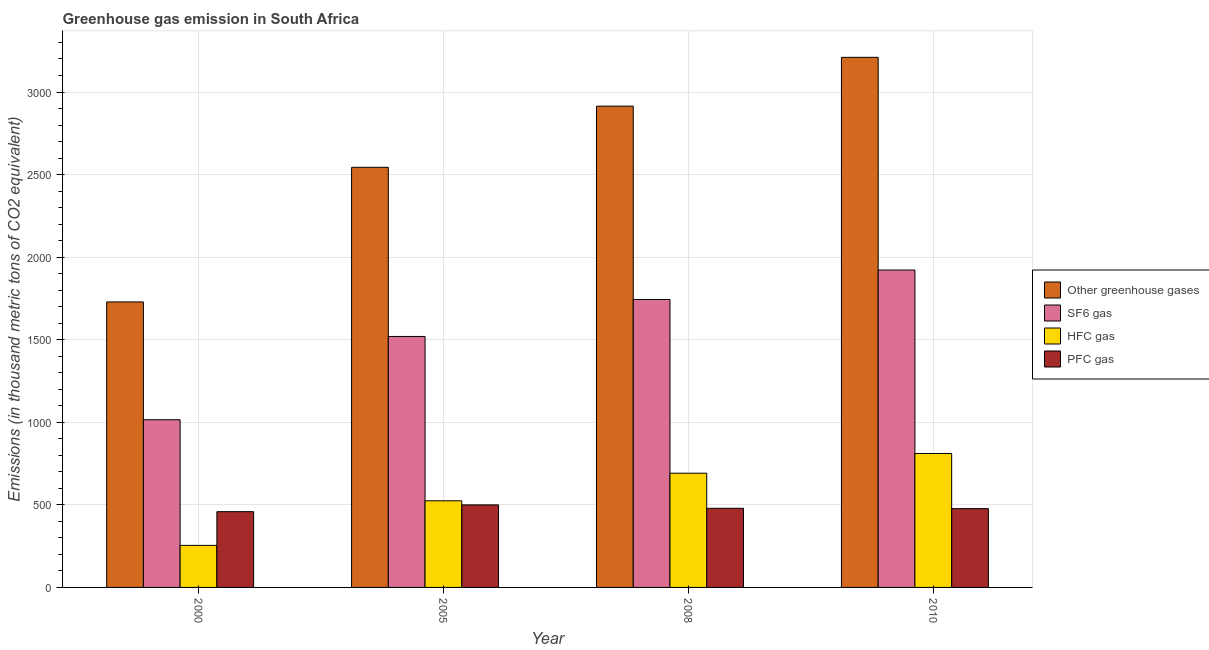How many different coloured bars are there?
Your answer should be very brief. 4. How many groups of bars are there?
Offer a very short reply. 4. Are the number of bars per tick equal to the number of legend labels?
Make the answer very short. Yes. How many bars are there on the 1st tick from the left?
Your answer should be compact. 4. In how many cases, is the number of bars for a given year not equal to the number of legend labels?
Provide a short and direct response. 0. What is the emission of pfc gas in 2010?
Offer a terse response. 477. Across all years, what is the maximum emission of hfc gas?
Provide a succinct answer. 811. Across all years, what is the minimum emission of pfc gas?
Offer a terse response. 458.8. In which year was the emission of pfc gas maximum?
Keep it short and to the point. 2005. In which year was the emission of sf6 gas minimum?
Offer a terse response. 2000. What is the total emission of pfc gas in the graph?
Keep it short and to the point. 1914.8. What is the difference between the emission of sf6 gas in 2000 and that in 2008?
Your answer should be compact. -728.2. What is the difference between the emission of hfc gas in 2005 and the emission of pfc gas in 2000?
Your response must be concise. 269.9. What is the average emission of pfc gas per year?
Your answer should be compact. 478.7. In the year 2005, what is the difference between the emission of hfc gas and emission of sf6 gas?
Keep it short and to the point. 0. In how many years, is the emission of sf6 gas greater than 2500 thousand metric tons?
Make the answer very short. 0. What is the ratio of the emission of sf6 gas in 2005 to that in 2008?
Keep it short and to the point. 0.87. Is the emission of sf6 gas in 2005 less than that in 2008?
Keep it short and to the point. Yes. What is the difference between the highest and the second highest emission of sf6 gas?
Offer a terse response. 178.4. What is the difference between the highest and the lowest emission of greenhouse gases?
Ensure brevity in your answer.  1481.2. What does the 4th bar from the left in 2005 represents?
Your answer should be very brief. PFC gas. What does the 3rd bar from the right in 2005 represents?
Offer a terse response. SF6 gas. Are the values on the major ticks of Y-axis written in scientific E-notation?
Provide a succinct answer. No. Where does the legend appear in the graph?
Give a very brief answer. Center right. How many legend labels are there?
Offer a terse response. 4. How are the legend labels stacked?
Provide a short and direct response. Vertical. What is the title of the graph?
Provide a succinct answer. Greenhouse gas emission in South Africa. What is the label or title of the Y-axis?
Give a very brief answer. Emissions (in thousand metric tons of CO2 equivalent). What is the Emissions (in thousand metric tons of CO2 equivalent) in Other greenhouse gases in 2000?
Give a very brief answer. 1728.8. What is the Emissions (in thousand metric tons of CO2 equivalent) of SF6 gas in 2000?
Your answer should be compact. 1015.4. What is the Emissions (in thousand metric tons of CO2 equivalent) in HFC gas in 2000?
Make the answer very short. 254.6. What is the Emissions (in thousand metric tons of CO2 equivalent) of PFC gas in 2000?
Provide a succinct answer. 458.8. What is the Emissions (in thousand metric tons of CO2 equivalent) of Other greenhouse gases in 2005?
Provide a short and direct response. 2544. What is the Emissions (in thousand metric tons of CO2 equivalent) of SF6 gas in 2005?
Make the answer very short. 1519.7. What is the Emissions (in thousand metric tons of CO2 equivalent) in HFC gas in 2005?
Your answer should be compact. 524.5. What is the Emissions (in thousand metric tons of CO2 equivalent) of PFC gas in 2005?
Provide a succinct answer. 499.8. What is the Emissions (in thousand metric tons of CO2 equivalent) in Other greenhouse gases in 2008?
Provide a short and direct response. 2914.4. What is the Emissions (in thousand metric tons of CO2 equivalent) of SF6 gas in 2008?
Your answer should be very brief. 1743.6. What is the Emissions (in thousand metric tons of CO2 equivalent) of HFC gas in 2008?
Keep it short and to the point. 691.6. What is the Emissions (in thousand metric tons of CO2 equivalent) in PFC gas in 2008?
Offer a very short reply. 479.2. What is the Emissions (in thousand metric tons of CO2 equivalent) in Other greenhouse gases in 2010?
Your response must be concise. 3210. What is the Emissions (in thousand metric tons of CO2 equivalent) in SF6 gas in 2010?
Provide a succinct answer. 1922. What is the Emissions (in thousand metric tons of CO2 equivalent) in HFC gas in 2010?
Make the answer very short. 811. What is the Emissions (in thousand metric tons of CO2 equivalent) in PFC gas in 2010?
Offer a very short reply. 477. Across all years, what is the maximum Emissions (in thousand metric tons of CO2 equivalent) of Other greenhouse gases?
Ensure brevity in your answer.  3210. Across all years, what is the maximum Emissions (in thousand metric tons of CO2 equivalent) of SF6 gas?
Your answer should be compact. 1922. Across all years, what is the maximum Emissions (in thousand metric tons of CO2 equivalent) in HFC gas?
Give a very brief answer. 811. Across all years, what is the maximum Emissions (in thousand metric tons of CO2 equivalent) of PFC gas?
Make the answer very short. 499.8. Across all years, what is the minimum Emissions (in thousand metric tons of CO2 equivalent) of Other greenhouse gases?
Offer a terse response. 1728.8. Across all years, what is the minimum Emissions (in thousand metric tons of CO2 equivalent) of SF6 gas?
Give a very brief answer. 1015.4. Across all years, what is the minimum Emissions (in thousand metric tons of CO2 equivalent) of HFC gas?
Provide a succinct answer. 254.6. Across all years, what is the minimum Emissions (in thousand metric tons of CO2 equivalent) in PFC gas?
Offer a very short reply. 458.8. What is the total Emissions (in thousand metric tons of CO2 equivalent) of Other greenhouse gases in the graph?
Your answer should be compact. 1.04e+04. What is the total Emissions (in thousand metric tons of CO2 equivalent) of SF6 gas in the graph?
Make the answer very short. 6200.7. What is the total Emissions (in thousand metric tons of CO2 equivalent) in HFC gas in the graph?
Offer a very short reply. 2281.7. What is the total Emissions (in thousand metric tons of CO2 equivalent) of PFC gas in the graph?
Offer a terse response. 1914.8. What is the difference between the Emissions (in thousand metric tons of CO2 equivalent) of Other greenhouse gases in 2000 and that in 2005?
Provide a succinct answer. -815.2. What is the difference between the Emissions (in thousand metric tons of CO2 equivalent) of SF6 gas in 2000 and that in 2005?
Give a very brief answer. -504.3. What is the difference between the Emissions (in thousand metric tons of CO2 equivalent) in HFC gas in 2000 and that in 2005?
Keep it short and to the point. -269.9. What is the difference between the Emissions (in thousand metric tons of CO2 equivalent) of PFC gas in 2000 and that in 2005?
Your answer should be compact. -41. What is the difference between the Emissions (in thousand metric tons of CO2 equivalent) of Other greenhouse gases in 2000 and that in 2008?
Provide a succinct answer. -1185.6. What is the difference between the Emissions (in thousand metric tons of CO2 equivalent) in SF6 gas in 2000 and that in 2008?
Provide a short and direct response. -728.2. What is the difference between the Emissions (in thousand metric tons of CO2 equivalent) of HFC gas in 2000 and that in 2008?
Provide a short and direct response. -437. What is the difference between the Emissions (in thousand metric tons of CO2 equivalent) of PFC gas in 2000 and that in 2008?
Offer a very short reply. -20.4. What is the difference between the Emissions (in thousand metric tons of CO2 equivalent) of Other greenhouse gases in 2000 and that in 2010?
Keep it short and to the point. -1481.2. What is the difference between the Emissions (in thousand metric tons of CO2 equivalent) of SF6 gas in 2000 and that in 2010?
Provide a short and direct response. -906.6. What is the difference between the Emissions (in thousand metric tons of CO2 equivalent) of HFC gas in 2000 and that in 2010?
Provide a short and direct response. -556.4. What is the difference between the Emissions (in thousand metric tons of CO2 equivalent) of PFC gas in 2000 and that in 2010?
Make the answer very short. -18.2. What is the difference between the Emissions (in thousand metric tons of CO2 equivalent) of Other greenhouse gases in 2005 and that in 2008?
Offer a terse response. -370.4. What is the difference between the Emissions (in thousand metric tons of CO2 equivalent) in SF6 gas in 2005 and that in 2008?
Make the answer very short. -223.9. What is the difference between the Emissions (in thousand metric tons of CO2 equivalent) of HFC gas in 2005 and that in 2008?
Ensure brevity in your answer.  -167.1. What is the difference between the Emissions (in thousand metric tons of CO2 equivalent) of PFC gas in 2005 and that in 2008?
Ensure brevity in your answer.  20.6. What is the difference between the Emissions (in thousand metric tons of CO2 equivalent) in Other greenhouse gases in 2005 and that in 2010?
Your answer should be compact. -666. What is the difference between the Emissions (in thousand metric tons of CO2 equivalent) in SF6 gas in 2005 and that in 2010?
Your answer should be very brief. -402.3. What is the difference between the Emissions (in thousand metric tons of CO2 equivalent) in HFC gas in 2005 and that in 2010?
Your answer should be very brief. -286.5. What is the difference between the Emissions (in thousand metric tons of CO2 equivalent) of PFC gas in 2005 and that in 2010?
Your answer should be very brief. 22.8. What is the difference between the Emissions (in thousand metric tons of CO2 equivalent) in Other greenhouse gases in 2008 and that in 2010?
Offer a terse response. -295.6. What is the difference between the Emissions (in thousand metric tons of CO2 equivalent) of SF6 gas in 2008 and that in 2010?
Make the answer very short. -178.4. What is the difference between the Emissions (in thousand metric tons of CO2 equivalent) in HFC gas in 2008 and that in 2010?
Provide a succinct answer. -119.4. What is the difference between the Emissions (in thousand metric tons of CO2 equivalent) of PFC gas in 2008 and that in 2010?
Keep it short and to the point. 2.2. What is the difference between the Emissions (in thousand metric tons of CO2 equivalent) in Other greenhouse gases in 2000 and the Emissions (in thousand metric tons of CO2 equivalent) in SF6 gas in 2005?
Provide a short and direct response. 209.1. What is the difference between the Emissions (in thousand metric tons of CO2 equivalent) of Other greenhouse gases in 2000 and the Emissions (in thousand metric tons of CO2 equivalent) of HFC gas in 2005?
Your answer should be compact. 1204.3. What is the difference between the Emissions (in thousand metric tons of CO2 equivalent) in Other greenhouse gases in 2000 and the Emissions (in thousand metric tons of CO2 equivalent) in PFC gas in 2005?
Keep it short and to the point. 1229. What is the difference between the Emissions (in thousand metric tons of CO2 equivalent) of SF6 gas in 2000 and the Emissions (in thousand metric tons of CO2 equivalent) of HFC gas in 2005?
Offer a terse response. 490.9. What is the difference between the Emissions (in thousand metric tons of CO2 equivalent) of SF6 gas in 2000 and the Emissions (in thousand metric tons of CO2 equivalent) of PFC gas in 2005?
Your response must be concise. 515.6. What is the difference between the Emissions (in thousand metric tons of CO2 equivalent) of HFC gas in 2000 and the Emissions (in thousand metric tons of CO2 equivalent) of PFC gas in 2005?
Offer a terse response. -245.2. What is the difference between the Emissions (in thousand metric tons of CO2 equivalent) in Other greenhouse gases in 2000 and the Emissions (in thousand metric tons of CO2 equivalent) in SF6 gas in 2008?
Provide a succinct answer. -14.8. What is the difference between the Emissions (in thousand metric tons of CO2 equivalent) in Other greenhouse gases in 2000 and the Emissions (in thousand metric tons of CO2 equivalent) in HFC gas in 2008?
Make the answer very short. 1037.2. What is the difference between the Emissions (in thousand metric tons of CO2 equivalent) in Other greenhouse gases in 2000 and the Emissions (in thousand metric tons of CO2 equivalent) in PFC gas in 2008?
Provide a succinct answer. 1249.6. What is the difference between the Emissions (in thousand metric tons of CO2 equivalent) in SF6 gas in 2000 and the Emissions (in thousand metric tons of CO2 equivalent) in HFC gas in 2008?
Give a very brief answer. 323.8. What is the difference between the Emissions (in thousand metric tons of CO2 equivalent) of SF6 gas in 2000 and the Emissions (in thousand metric tons of CO2 equivalent) of PFC gas in 2008?
Provide a succinct answer. 536.2. What is the difference between the Emissions (in thousand metric tons of CO2 equivalent) of HFC gas in 2000 and the Emissions (in thousand metric tons of CO2 equivalent) of PFC gas in 2008?
Offer a very short reply. -224.6. What is the difference between the Emissions (in thousand metric tons of CO2 equivalent) in Other greenhouse gases in 2000 and the Emissions (in thousand metric tons of CO2 equivalent) in SF6 gas in 2010?
Your answer should be very brief. -193.2. What is the difference between the Emissions (in thousand metric tons of CO2 equivalent) of Other greenhouse gases in 2000 and the Emissions (in thousand metric tons of CO2 equivalent) of HFC gas in 2010?
Your response must be concise. 917.8. What is the difference between the Emissions (in thousand metric tons of CO2 equivalent) in Other greenhouse gases in 2000 and the Emissions (in thousand metric tons of CO2 equivalent) in PFC gas in 2010?
Make the answer very short. 1251.8. What is the difference between the Emissions (in thousand metric tons of CO2 equivalent) of SF6 gas in 2000 and the Emissions (in thousand metric tons of CO2 equivalent) of HFC gas in 2010?
Keep it short and to the point. 204.4. What is the difference between the Emissions (in thousand metric tons of CO2 equivalent) of SF6 gas in 2000 and the Emissions (in thousand metric tons of CO2 equivalent) of PFC gas in 2010?
Offer a terse response. 538.4. What is the difference between the Emissions (in thousand metric tons of CO2 equivalent) of HFC gas in 2000 and the Emissions (in thousand metric tons of CO2 equivalent) of PFC gas in 2010?
Your response must be concise. -222.4. What is the difference between the Emissions (in thousand metric tons of CO2 equivalent) in Other greenhouse gases in 2005 and the Emissions (in thousand metric tons of CO2 equivalent) in SF6 gas in 2008?
Offer a very short reply. 800.4. What is the difference between the Emissions (in thousand metric tons of CO2 equivalent) in Other greenhouse gases in 2005 and the Emissions (in thousand metric tons of CO2 equivalent) in HFC gas in 2008?
Your answer should be very brief. 1852.4. What is the difference between the Emissions (in thousand metric tons of CO2 equivalent) in Other greenhouse gases in 2005 and the Emissions (in thousand metric tons of CO2 equivalent) in PFC gas in 2008?
Provide a short and direct response. 2064.8. What is the difference between the Emissions (in thousand metric tons of CO2 equivalent) of SF6 gas in 2005 and the Emissions (in thousand metric tons of CO2 equivalent) of HFC gas in 2008?
Your answer should be very brief. 828.1. What is the difference between the Emissions (in thousand metric tons of CO2 equivalent) of SF6 gas in 2005 and the Emissions (in thousand metric tons of CO2 equivalent) of PFC gas in 2008?
Your answer should be compact. 1040.5. What is the difference between the Emissions (in thousand metric tons of CO2 equivalent) in HFC gas in 2005 and the Emissions (in thousand metric tons of CO2 equivalent) in PFC gas in 2008?
Offer a terse response. 45.3. What is the difference between the Emissions (in thousand metric tons of CO2 equivalent) of Other greenhouse gases in 2005 and the Emissions (in thousand metric tons of CO2 equivalent) of SF6 gas in 2010?
Ensure brevity in your answer.  622. What is the difference between the Emissions (in thousand metric tons of CO2 equivalent) of Other greenhouse gases in 2005 and the Emissions (in thousand metric tons of CO2 equivalent) of HFC gas in 2010?
Your answer should be compact. 1733. What is the difference between the Emissions (in thousand metric tons of CO2 equivalent) of Other greenhouse gases in 2005 and the Emissions (in thousand metric tons of CO2 equivalent) of PFC gas in 2010?
Provide a succinct answer. 2067. What is the difference between the Emissions (in thousand metric tons of CO2 equivalent) in SF6 gas in 2005 and the Emissions (in thousand metric tons of CO2 equivalent) in HFC gas in 2010?
Give a very brief answer. 708.7. What is the difference between the Emissions (in thousand metric tons of CO2 equivalent) in SF6 gas in 2005 and the Emissions (in thousand metric tons of CO2 equivalent) in PFC gas in 2010?
Offer a terse response. 1042.7. What is the difference between the Emissions (in thousand metric tons of CO2 equivalent) of HFC gas in 2005 and the Emissions (in thousand metric tons of CO2 equivalent) of PFC gas in 2010?
Offer a very short reply. 47.5. What is the difference between the Emissions (in thousand metric tons of CO2 equivalent) in Other greenhouse gases in 2008 and the Emissions (in thousand metric tons of CO2 equivalent) in SF6 gas in 2010?
Ensure brevity in your answer.  992.4. What is the difference between the Emissions (in thousand metric tons of CO2 equivalent) in Other greenhouse gases in 2008 and the Emissions (in thousand metric tons of CO2 equivalent) in HFC gas in 2010?
Ensure brevity in your answer.  2103.4. What is the difference between the Emissions (in thousand metric tons of CO2 equivalent) in Other greenhouse gases in 2008 and the Emissions (in thousand metric tons of CO2 equivalent) in PFC gas in 2010?
Your answer should be compact. 2437.4. What is the difference between the Emissions (in thousand metric tons of CO2 equivalent) of SF6 gas in 2008 and the Emissions (in thousand metric tons of CO2 equivalent) of HFC gas in 2010?
Provide a succinct answer. 932.6. What is the difference between the Emissions (in thousand metric tons of CO2 equivalent) of SF6 gas in 2008 and the Emissions (in thousand metric tons of CO2 equivalent) of PFC gas in 2010?
Offer a terse response. 1266.6. What is the difference between the Emissions (in thousand metric tons of CO2 equivalent) in HFC gas in 2008 and the Emissions (in thousand metric tons of CO2 equivalent) in PFC gas in 2010?
Your answer should be very brief. 214.6. What is the average Emissions (in thousand metric tons of CO2 equivalent) in Other greenhouse gases per year?
Offer a terse response. 2599.3. What is the average Emissions (in thousand metric tons of CO2 equivalent) in SF6 gas per year?
Provide a succinct answer. 1550.17. What is the average Emissions (in thousand metric tons of CO2 equivalent) of HFC gas per year?
Keep it short and to the point. 570.42. What is the average Emissions (in thousand metric tons of CO2 equivalent) in PFC gas per year?
Provide a short and direct response. 478.7. In the year 2000, what is the difference between the Emissions (in thousand metric tons of CO2 equivalent) of Other greenhouse gases and Emissions (in thousand metric tons of CO2 equivalent) of SF6 gas?
Keep it short and to the point. 713.4. In the year 2000, what is the difference between the Emissions (in thousand metric tons of CO2 equivalent) in Other greenhouse gases and Emissions (in thousand metric tons of CO2 equivalent) in HFC gas?
Your response must be concise. 1474.2. In the year 2000, what is the difference between the Emissions (in thousand metric tons of CO2 equivalent) of Other greenhouse gases and Emissions (in thousand metric tons of CO2 equivalent) of PFC gas?
Your response must be concise. 1270. In the year 2000, what is the difference between the Emissions (in thousand metric tons of CO2 equivalent) in SF6 gas and Emissions (in thousand metric tons of CO2 equivalent) in HFC gas?
Make the answer very short. 760.8. In the year 2000, what is the difference between the Emissions (in thousand metric tons of CO2 equivalent) of SF6 gas and Emissions (in thousand metric tons of CO2 equivalent) of PFC gas?
Offer a terse response. 556.6. In the year 2000, what is the difference between the Emissions (in thousand metric tons of CO2 equivalent) in HFC gas and Emissions (in thousand metric tons of CO2 equivalent) in PFC gas?
Offer a very short reply. -204.2. In the year 2005, what is the difference between the Emissions (in thousand metric tons of CO2 equivalent) of Other greenhouse gases and Emissions (in thousand metric tons of CO2 equivalent) of SF6 gas?
Your answer should be compact. 1024.3. In the year 2005, what is the difference between the Emissions (in thousand metric tons of CO2 equivalent) in Other greenhouse gases and Emissions (in thousand metric tons of CO2 equivalent) in HFC gas?
Keep it short and to the point. 2019.5. In the year 2005, what is the difference between the Emissions (in thousand metric tons of CO2 equivalent) in Other greenhouse gases and Emissions (in thousand metric tons of CO2 equivalent) in PFC gas?
Offer a very short reply. 2044.2. In the year 2005, what is the difference between the Emissions (in thousand metric tons of CO2 equivalent) of SF6 gas and Emissions (in thousand metric tons of CO2 equivalent) of HFC gas?
Keep it short and to the point. 995.2. In the year 2005, what is the difference between the Emissions (in thousand metric tons of CO2 equivalent) of SF6 gas and Emissions (in thousand metric tons of CO2 equivalent) of PFC gas?
Provide a short and direct response. 1019.9. In the year 2005, what is the difference between the Emissions (in thousand metric tons of CO2 equivalent) of HFC gas and Emissions (in thousand metric tons of CO2 equivalent) of PFC gas?
Keep it short and to the point. 24.7. In the year 2008, what is the difference between the Emissions (in thousand metric tons of CO2 equivalent) of Other greenhouse gases and Emissions (in thousand metric tons of CO2 equivalent) of SF6 gas?
Offer a terse response. 1170.8. In the year 2008, what is the difference between the Emissions (in thousand metric tons of CO2 equivalent) of Other greenhouse gases and Emissions (in thousand metric tons of CO2 equivalent) of HFC gas?
Make the answer very short. 2222.8. In the year 2008, what is the difference between the Emissions (in thousand metric tons of CO2 equivalent) in Other greenhouse gases and Emissions (in thousand metric tons of CO2 equivalent) in PFC gas?
Your response must be concise. 2435.2. In the year 2008, what is the difference between the Emissions (in thousand metric tons of CO2 equivalent) of SF6 gas and Emissions (in thousand metric tons of CO2 equivalent) of HFC gas?
Offer a terse response. 1052. In the year 2008, what is the difference between the Emissions (in thousand metric tons of CO2 equivalent) in SF6 gas and Emissions (in thousand metric tons of CO2 equivalent) in PFC gas?
Keep it short and to the point. 1264.4. In the year 2008, what is the difference between the Emissions (in thousand metric tons of CO2 equivalent) in HFC gas and Emissions (in thousand metric tons of CO2 equivalent) in PFC gas?
Provide a succinct answer. 212.4. In the year 2010, what is the difference between the Emissions (in thousand metric tons of CO2 equivalent) of Other greenhouse gases and Emissions (in thousand metric tons of CO2 equivalent) of SF6 gas?
Your answer should be compact. 1288. In the year 2010, what is the difference between the Emissions (in thousand metric tons of CO2 equivalent) in Other greenhouse gases and Emissions (in thousand metric tons of CO2 equivalent) in HFC gas?
Offer a terse response. 2399. In the year 2010, what is the difference between the Emissions (in thousand metric tons of CO2 equivalent) of Other greenhouse gases and Emissions (in thousand metric tons of CO2 equivalent) of PFC gas?
Give a very brief answer. 2733. In the year 2010, what is the difference between the Emissions (in thousand metric tons of CO2 equivalent) in SF6 gas and Emissions (in thousand metric tons of CO2 equivalent) in HFC gas?
Your response must be concise. 1111. In the year 2010, what is the difference between the Emissions (in thousand metric tons of CO2 equivalent) of SF6 gas and Emissions (in thousand metric tons of CO2 equivalent) of PFC gas?
Make the answer very short. 1445. In the year 2010, what is the difference between the Emissions (in thousand metric tons of CO2 equivalent) in HFC gas and Emissions (in thousand metric tons of CO2 equivalent) in PFC gas?
Your answer should be very brief. 334. What is the ratio of the Emissions (in thousand metric tons of CO2 equivalent) in Other greenhouse gases in 2000 to that in 2005?
Ensure brevity in your answer.  0.68. What is the ratio of the Emissions (in thousand metric tons of CO2 equivalent) of SF6 gas in 2000 to that in 2005?
Make the answer very short. 0.67. What is the ratio of the Emissions (in thousand metric tons of CO2 equivalent) of HFC gas in 2000 to that in 2005?
Your answer should be very brief. 0.49. What is the ratio of the Emissions (in thousand metric tons of CO2 equivalent) in PFC gas in 2000 to that in 2005?
Keep it short and to the point. 0.92. What is the ratio of the Emissions (in thousand metric tons of CO2 equivalent) in Other greenhouse gases in 2000 to that in 2008?
Give a very brief answer. 0.59. What is the ratio of the Emissions (in thousand metric tons of CO2 equivalent) in SF6 gas in 2000 to that in 2008?
Give a very brief answer. 0.58. What is the ratio of the Emissions (in thousand metric tons of CO2 equivalent) of HFC gas in 2000 to that in 2008?
Offer a very short reply. 0.37. What is the ratio of the Emissions (in thousand metric tons of CO2 equivalent) in PFC gas in 2000 to that in 2008?
Your answer should be compact. 0.96. What is the ratio of the Emissions (in thousand metric tons of CO2 equivalent) in Other greenhouse gases in 2000 to that in 2010?
Offer a terse response. 0.54. What is the ratio of the Emissions (in thousand metric tons of CO2 equivalent) in SF6 gas in 2000 to that in 2010?
Your response must be concise. 0.53. What is the ratio of the Emissions (in thousand metric tons of CO2 equivalent) in HFC gas in 2000 to that in 2010?
Keep it short and to the point. 0.31. What is the ratio of the Emissions (in thousand metric tons of CO2 equivalent) in PFC gas in 2000 to that in 2010?
Give a very brief answer. 0.96. What is the ratio of the Emissions (in thousand metric tons of CO2 equivalent) in Other greenhouse gases in 2005 to that in 2008?
Give a very brief answer. 0.87. What is the ratio of the Emissions (in thousand metric tons of CO2 equivalent) of SF6 gas in 2005 to that in 2008?
Your answer should be very brief. 0.87. What is the ratio of the Emissions (in thousand metric tons of CO2 equivalent) of HFC gas in 2005 to that in 2008?
Your answer should be compact. 0.76. What is the ratio of the Emissions (in thousand metric tons of CO2 equivalent) in PFC gas in 2005 to that in 2008?
Give a very brief answer. 1.04. What is the ratio of the Emissions (in thousand metric tons of CO2 equivalent) of Other greenhouse gases in 2005 to that in 2010?
Make the answer very short. 0.79. What is the ratio of the Emissions (in thousand metric tons of CO2 equivalent) in SF6 gas in 2005 to that in 2010?
Keep it short and to the point. 0.79. What is the ratio of the Emissions (in thousand metric tons of CO2 equivalent) in HFC gas in 2005 to that in 2010?
Provide a short and direct response. 0.65. What is the ratio of the Emissions (in thousand metric tons of CO2 equivalent) in PFC gas in 2005 to that in 2010?
Keep it short and to the point. 1.05. What is the ratio of the Emissions (in thousand metric tons of CO2 equivalent) in Other greenhouse gases in 2008 to that in 2010?
Your answer should be compact. 0.91. What is the ratio of the Emissions (in thousand metric tons of CO2 equivalent) in SF6 gas in 2008 to that in 2010?
Ensure brevity in your answer.  0.91. What is the ratio of the Emissions (in thousand metric tons of CO2 equivalent) of HFC gas in 2008 to that in 2010?
Your response must be concise. 0.85. What is the difference between the highest and the second highest Emissions (in thousand metric tons of CO2 equivalent) of Other greenhouse gases?
Give a very brief answer. 295.6. What is the difference between the highest and the second highest Emissions (in thousand metric tons of CO2 equivalent) in SF6 gas?
Keep it short and to the point. 178.4. What is the difference between the highest and the second highest Emissions (in thousand metric tons of CO2 equivalent) of HFC gas?
Ensure brevity in your answer.  119.4. What is the difference between the highest and the second highest Emissions (in thousand metric tons of CO2 equivalent) in PFC gas?
Keep it short and to the point. 20.6. What is the difference between the highest and the lowest Emissions (in thousand metric tons of CO2 equivalent) in Other greenhouse gases?
Give a very brief answer. 1481.2. What is the difference between the highest and the lowest Emissions (in thousand metric tons of CO2 equivalent) of SF6 gas?
Offer a very short reply. 906.6. What is the difference between the highest and the lowest Emissions (in thousand metric tons of CO2 equivalent) in HFC gas?
Offer a very short reply. 556.4. 